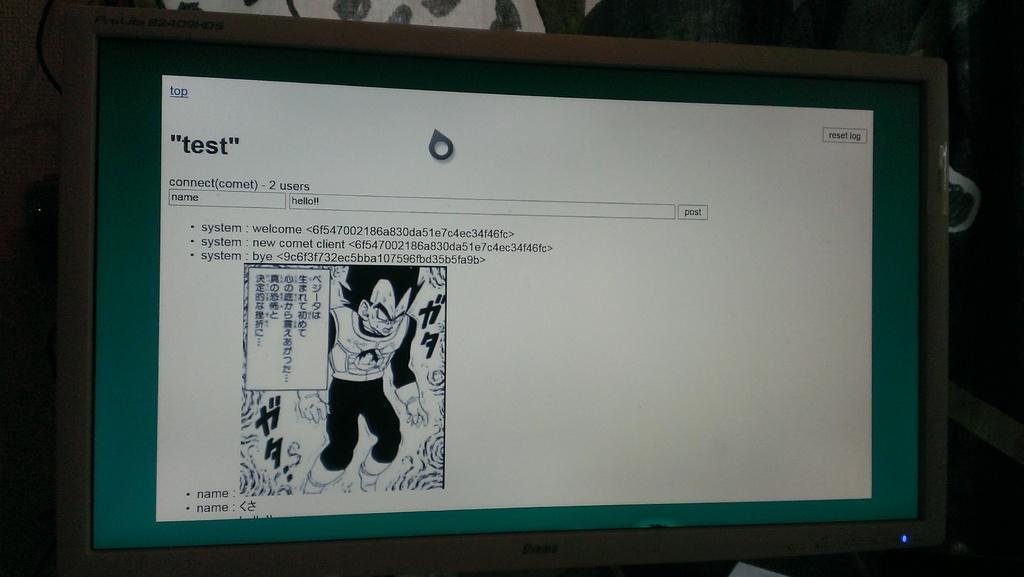<image>
Give a short and clear explanation of the subsequent image. On the computer screen there is a test for someone to complete. 